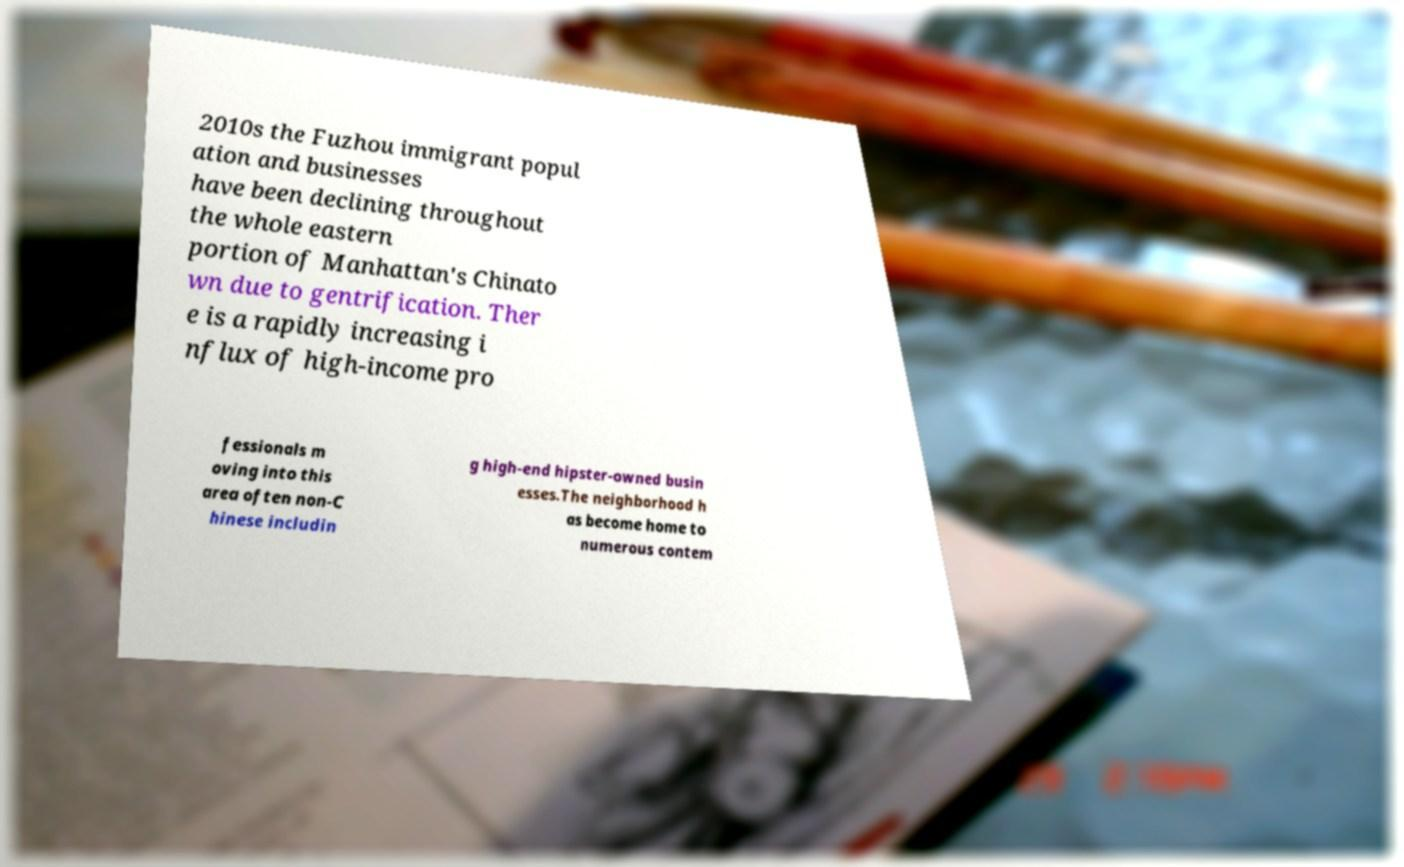Could you assist in decoding the text presented in this image and type it out clearly? 2010s the Fuzhou immigrant popul ation and businesses have been declining throughout the whole eastern portion of Manhattan's Chinato wn due to gentrification. Ther e is a rapidly increasing i nflux of high-income pro fessionals m oving into this area often non-C hinese includin g high-end hipster-owned busin esses.The neighborhood h as become home to numerous contem 